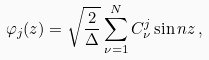Convert formula to latex. <formula><loc_0><loc_0><loc_500><loc_500>\varphi _ { j } ( z ) = \sqrt { \frac { 2 } { \Delta } } \sum _ { \nu = 1 } ^ { N } C _ { \nu } ^ { j } \sin n z \, ,</formula> 